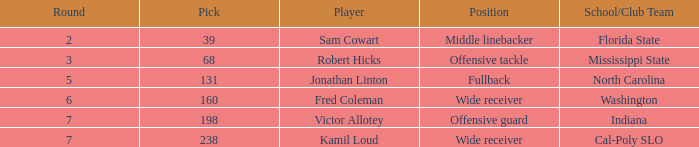Which participant has a round under 5 and belongs to a school/club team in florida state? Sam Cowart. 